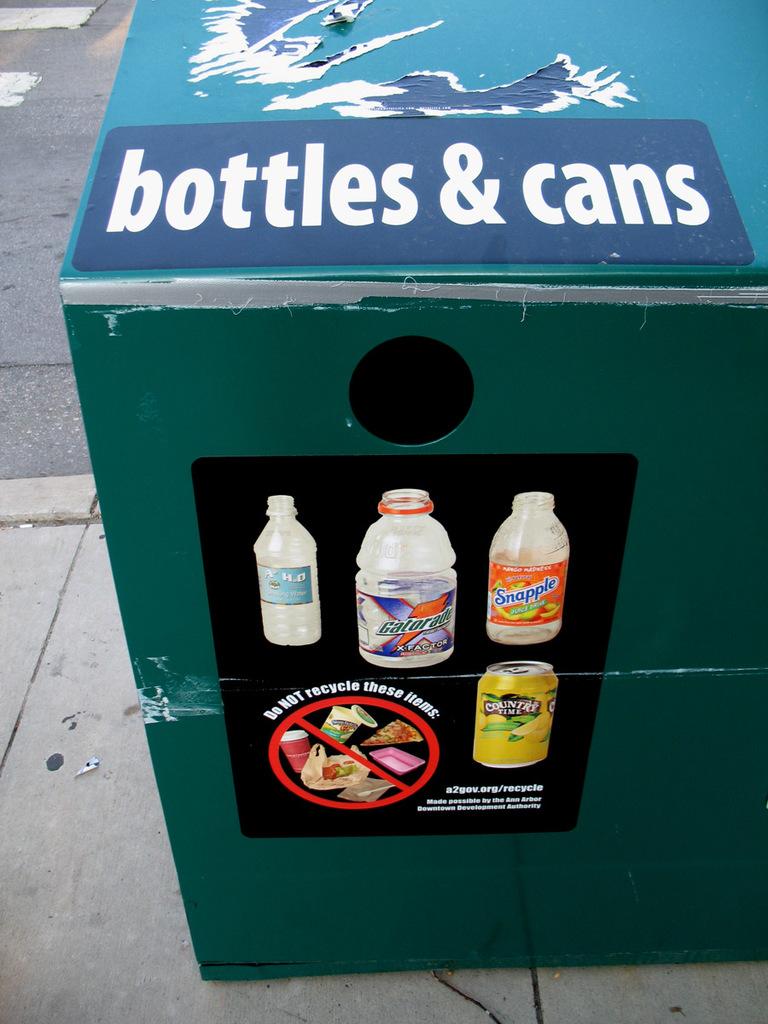What two types of items does it say to put in the container?
Offer a very short reply. Bottles and cans. What brands of beverages is on the bottles?
Provide a short and direct response. Gatorade. 